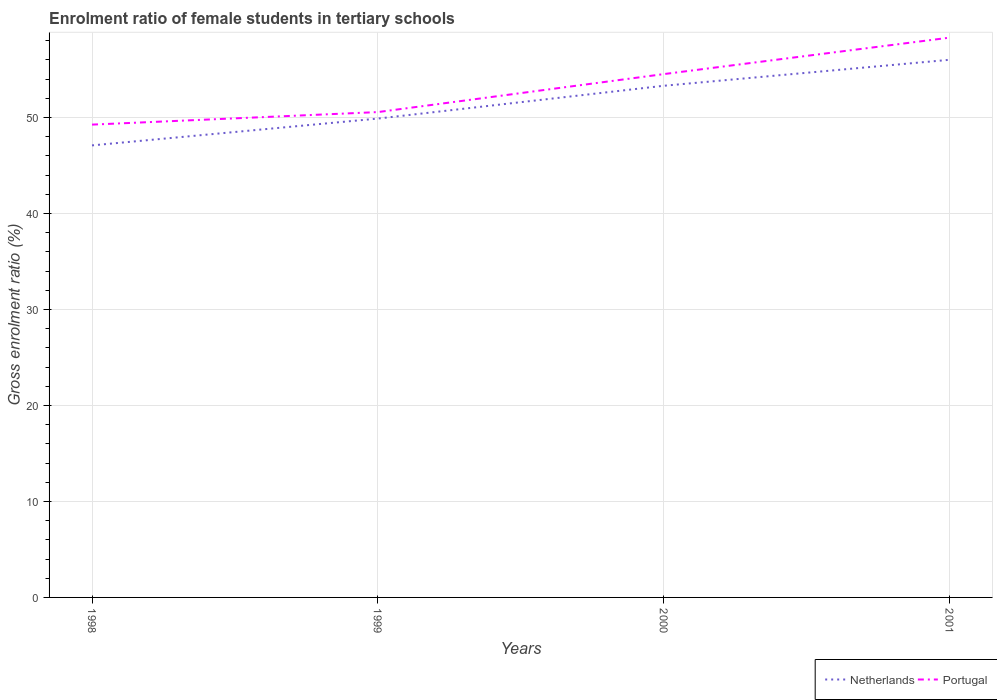Does the line corresponding to Portugal intersect with the line corresponding to Netherlands?
Provide a short and direct response. No. Across all years, what is the maximum enrolment ratio of female students in tertiary schools in Portugal?
Offer a terse response. 49.27. What is the total enrolment ratio of female students in tertiary schools in Netherlands in the graph?
Offer a terse response. -2.71. What is the difference between the highest and the second highest enrolment ratio of female students in tertiary schools in Portugal?
Give a very brief answer. 9.06. Are the values on the major ticks of Y-axis written in scientific E-notation?
Make the answer very short. No. Where does the legend appear in the graph?
Your response must be concise. Bottom right. How many legend labels are there?
Make the answer very short. 2. What is the title of the graph?
Offer a very short reply. Enrolment ratio of female students in tertiary schools. Does "Samoa" appear as one of the legend labels in the graph?
Provide a succinct answer. No. What is the label or title of the X-axis?
Offer a terse response. Years. What is the Gross enrolment ratio (%) of Netherlands in 1998?
Your answer should be very brief. 47.1. What is the Gross enrolment ratio (%) in Portugal in 1998?
Offer a very short reply. 49.27. What is the Gross enrolment ratio (%) of Netherlands in 1999?
Offer a terse response. 49.9. What is the Gross enrolment ratio (%) in Portugal in 1999?
Your response must be concise. 50.57. What is the Gross enrolment ratio (%) of Netherlands in 2000?
Give a very brief answer. 53.31. What is the Gross enrolment ratio (%) of Portugal in 2000?
Your answer should be compact. 54.53. What is the Gross enrolment ratio (%) of Netherlands in 2001?
Offer a terse response. 56.02. What is the Gross enrolment ratio (%) in Portugal in 2001?
Offer a terse response. 58.33. Across all years, what is the maximum Gross enrolment ratio (%) in Netherlands?
Ensure brevity in your answer.  56.02. Across all years, what is the maximum Gross enrolment ratio (%) in Portugal?
Make the answer very short. 58.33. Across all years, what is the minimum Gross enrolment ratio (%) in Netherlands?
Your answer should be very brief. 47.1. Across all years, what is the minimum Gross enrolment ratio (%) of Portugal?
Your response must be concise. 49.27. What is the total Gross enrolment ratio (%) of Netherlands in the graph?
Offer a very short reply. 206.34. What is the total Gross enrolment ratio (%) in Portugal in the graph?
Give a very brief answer. 212.7. What is the difference between the Gross enrolment ratio (%) of Netherlands in 1998 and that in 1999?
Offer a very short reply. -2.79. What is the difference between the Gross enrolment ratio (%) in Portugal in 1998 and that in 1999?
Offer a terse response. -1.31. What is the difference between the Gross enrolment ratio (%) in Netherlands in 1998 and that in 2000?
Keep it short and to the point. -6.21. What is the difference between the Gross enrolment ratio (%) of Portugal in 1998 and that in 2000?
Keep it short and to the point. -5.26. What is the difference between the Gross enrolment ratio (%) of Netherlands in 1998 and that in 2001?
Make the answer very short. -8.92. What is the difference between the Gross enrolment ratio (%) in Portugal in 1998 and that in 2001?
Your answer should be very brief. -9.06. What is the difference between the Gross enrolment ratio (%) of Netherlands in 1999 and that in 2000?
Your response must be concise. -3.42. What is the difference between the Gross enrolment ratio (%) of Portugal in 1999 and that in 2000?
Provide a short and direct response. -3.96. What is the difference between the Gross enrolment ratio (%) in Netherlands in 1999 and that in 2001?
Your answer should be compact. -6.13. What is the difference between the Gross enrolment ratio (%) of Portugal in 1999 and that in 2001?
Keep it short and to the point. -7.76. What is the difference between the Gross enrolment ratio (%) of Netherlands in 2000 and that in 2001?
Your answer should be very brief. -2.71. What is the difference between the Gross enrolment ratio (%) in Portugal in 2000 and that in 2001?
Provide a succinct answer. -3.8. What is the difference between the Gross enrolment ratio (%) of Netherlands in 1998 and the Gross enrolment ratio (%) of Portugal in 1999?
Your answer should be very brief. -3.47. What is the difference between the Gross enrolment ratio (%) in Netherlands in 1998 and the Gross enrolment ratio (%) in Portugal in 2000?
Provide a short and direct response. -7.43. What is the difference between the Gross enrolment ratio (%) in Netherlands in 1998 and the Gross enrolment ratio (%) in Portugal in 2001?
Offer a very short reply. -11.23. What is the difference between the Gross enrolment ratio (%) of Netherlands in 1999 and the Gross enrolment ratio (%) of Portugal in 2000?
Offer a terse response. -4.63. What is the difference between the Gross enrolment ratio (%) of Netherlands in 1999 and the Gross enrolment ratio (%) of Portugal in 2001?
Your answer should be compact. -8.43. What is the difference between the Gross enrolment ratio (%) in Netherlands in 2000 and the Gross enrolment ratio (%) in Portugal in 2001?
Provide a succinct answer. -5.01. What is the average Gross enrolment ratio (%) of Netherlands per year?
Offer a very short reply. 51.58. What is the average Gross enrolment ratio (%) in Portugal per year?
Make the answer very short. 53.18. In the year 1998, what is the difference between the Gross enrolment ratio (%) in Netherlands and Gross enrolment ratio (%) in Portugal?
Your answer should be very brief. -2.16. In the year 1999, what is the difference between the Gross enrolment ratio (%) in Netherlands and Gross enrolment ratio (%) in Portugal?
Your response must be concise. -0.68. In the year 2000, what is the difference between the Gross enrolment ratio (%) in Netherlands and Gross enrolment ratio (%) in Portugal?
Provide a succinct answer. -1.22. In the year 2001, what is the difference between the Gross enrolment ratio (%) in Netherlands and Gross enrolment ratio (%) in Portugal?
Provide a short and direct response. -2.31. What is the ratio of the Gross enrolment ratio (%) in Netherlands in 1998 to that in 1999?
Make the answer very short. 0.94. What is the ratio of the Gross enrolment ratio (%) in Portugal in 1998 to that in 1999?
Offer a terse response. 0.97. What is the ratio of the Gross enrolment ratio (%) in Netherlands in 1998 to that in 2000?
Provide a succinct answer. 0.88. What is the ratio of the Gross enrolment ratio (%) of Portugal in 1998 to that in 2000?
Provide a short and direct response. 0.9. What is the ratio of the Gross enrolment ratio (%) in Netherlands in 1998 to that in 2001?
Keep it short and to the point. 0.84. What is the ratio of the Gross enrolment ratio (%) of Portugal in 1998 to that in 2001?
Your answer should be compact. 0.84. What is the ratio of the Gross enrolment ratio (%) of Netherlands in 1999 to that in 2000?
Make the answer very short. 0.94. What is the ratio of the Gross enrolment ratio (%) of Portugal in 1999 to that in 2000?
Your answer should be compact. 0.93. What is the ratio of the Gross enrolment ratio (%) in Netherlands in 1999 to that in 2001?
Offer a very short reply. 0.89. What is the ratio of the Gross enrolment ratio (%) in Portugal in 1999 to that in 2001?
Keep it short and to the point. 0.87. What is the ratio of the Gross enrolment ratio (%) of Netherlands in 2000 to that in 2001?
Offer a very short reply. 0.95. What is the ratio of the Gross enrolment ratio (%) of Portugal in 2000 to that in 2001?
Make the answer very short. 0.93. What is the difference between the highest and the second highest Gross enrolment ratio (%) in Netherlands?
Provide a succinct answer. 2.71. What is the difference between the highest and the second highest Gross enrolment ratio (%) of Portugal?
Your response must be concise. 3.8. What is the difference between the highest and the lowest Gross enrolment ratio (%) of Netherlands?
Your response must be concise. 8.92. What is the difference between the highest and the lowest Gross enrolment ratio (%) in Portugal?
Keep it short and to the point. 9.06. 